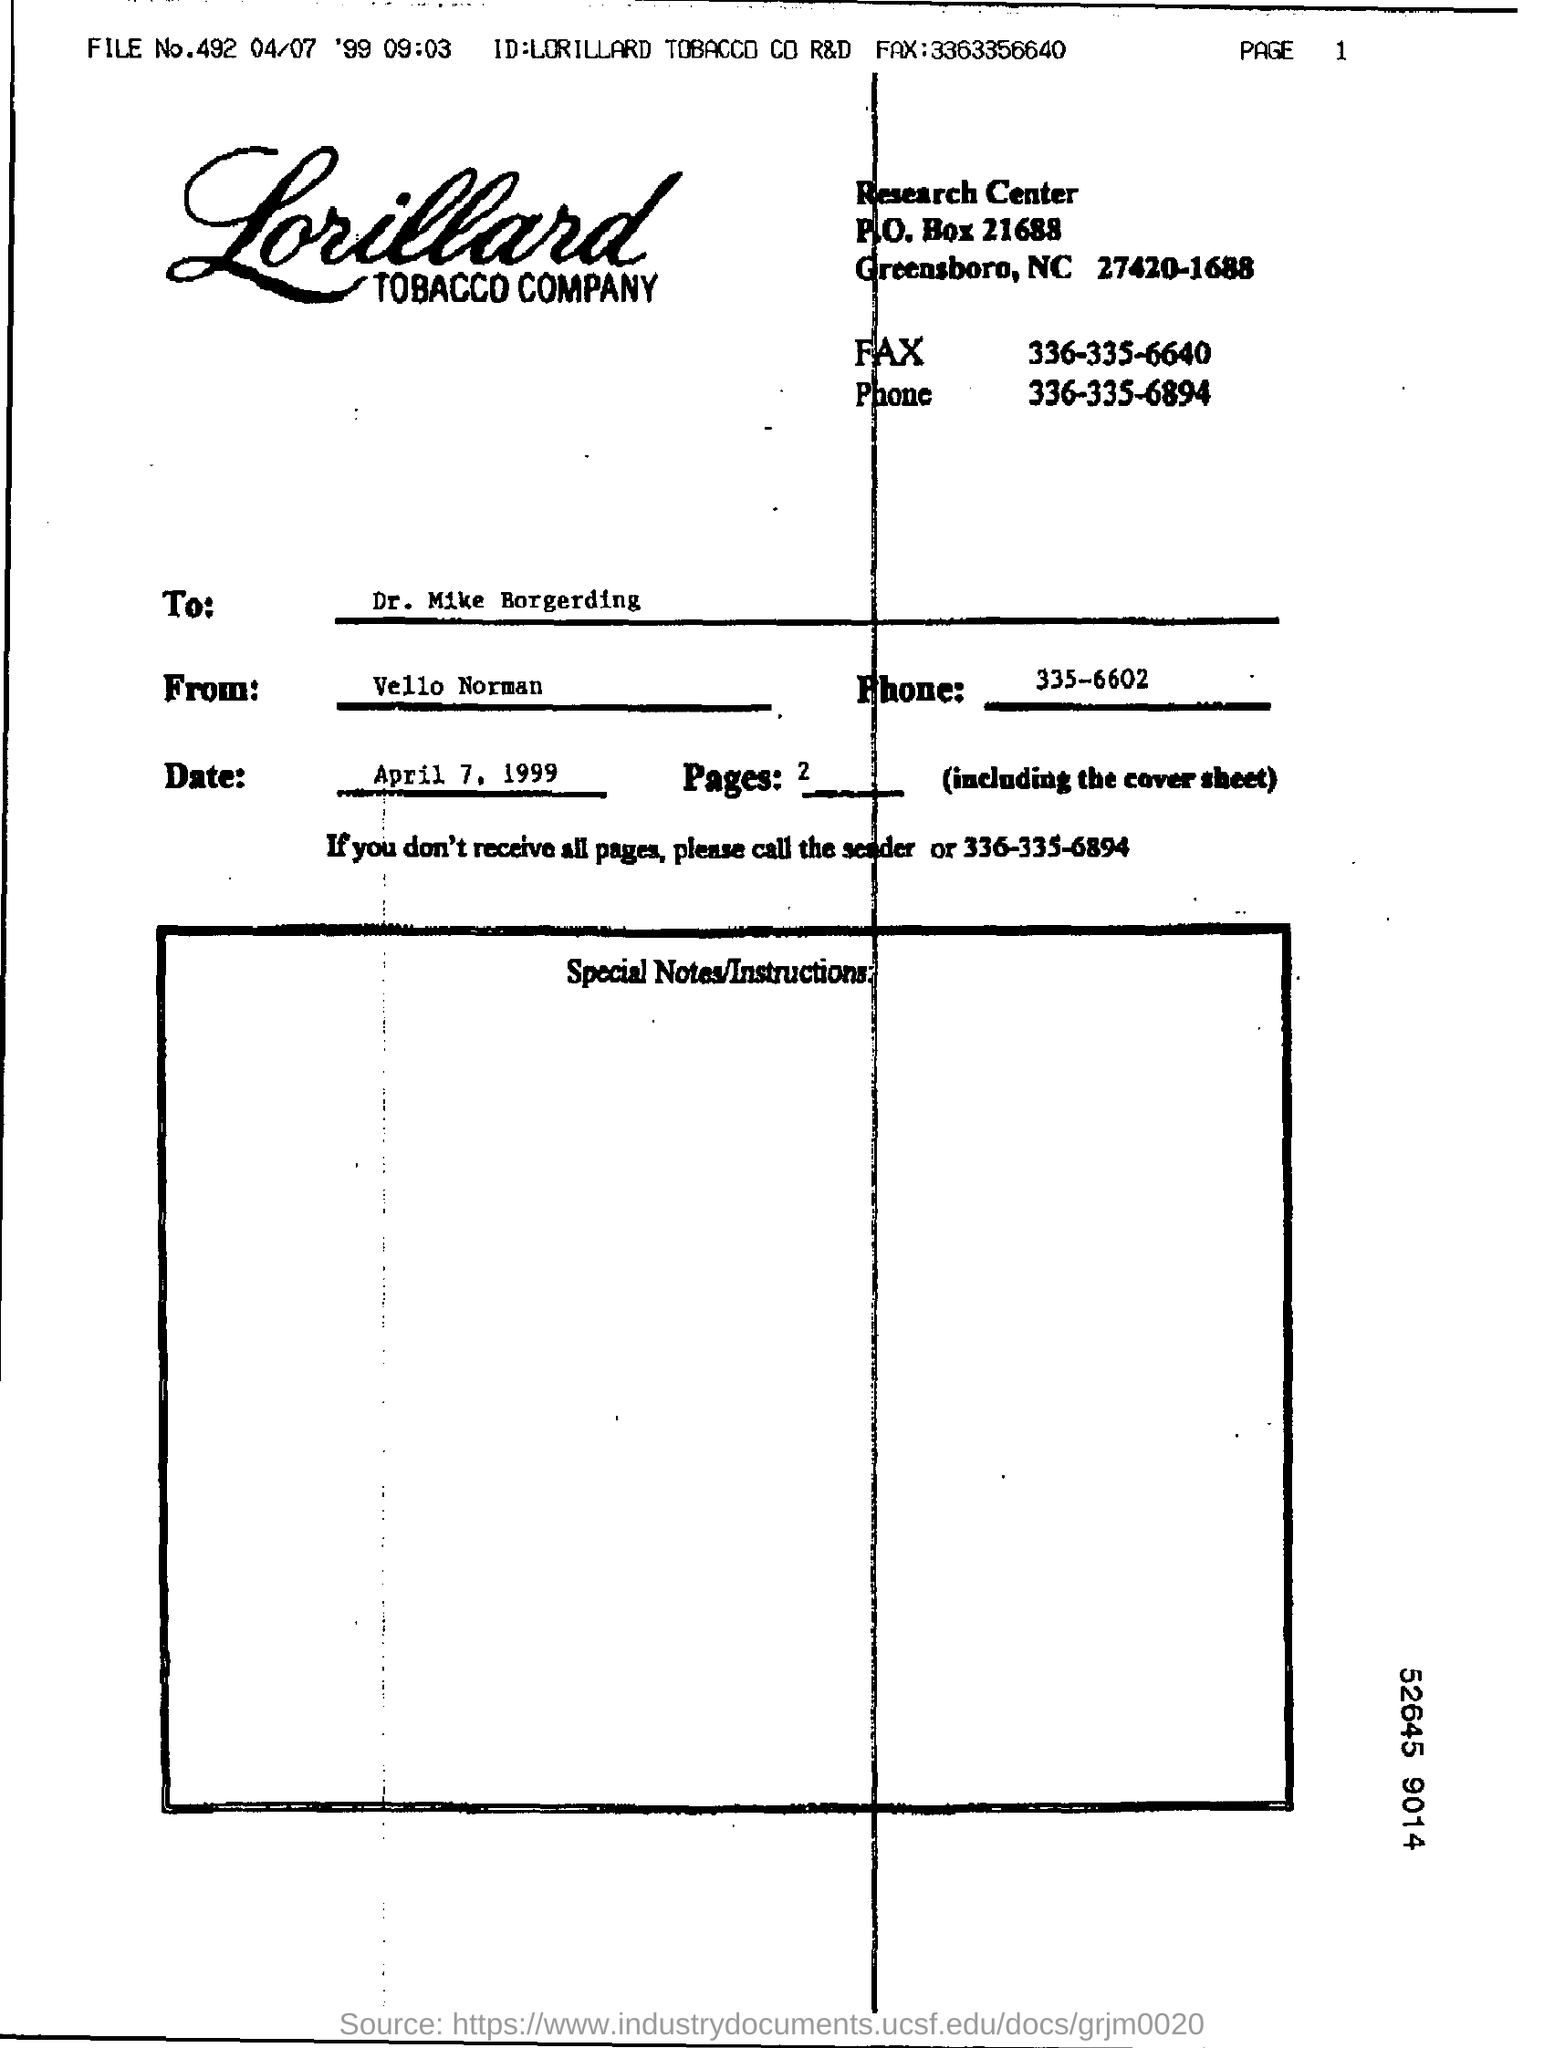What is the name of the tobacco company?
Provide a short and direct response. Lorillard. What is the date mentioned?
Your answer should be compact. April 7, 1999. By whom is this document written?
Give a very brief answer. Vello Norman. To whom is this document addressed?
Offer a very short reply. Dr. Mike Borgerding. 